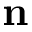Convert formula to latex. <formula><loc_0><loc_0><loc_500><loc_500>n</formula> 